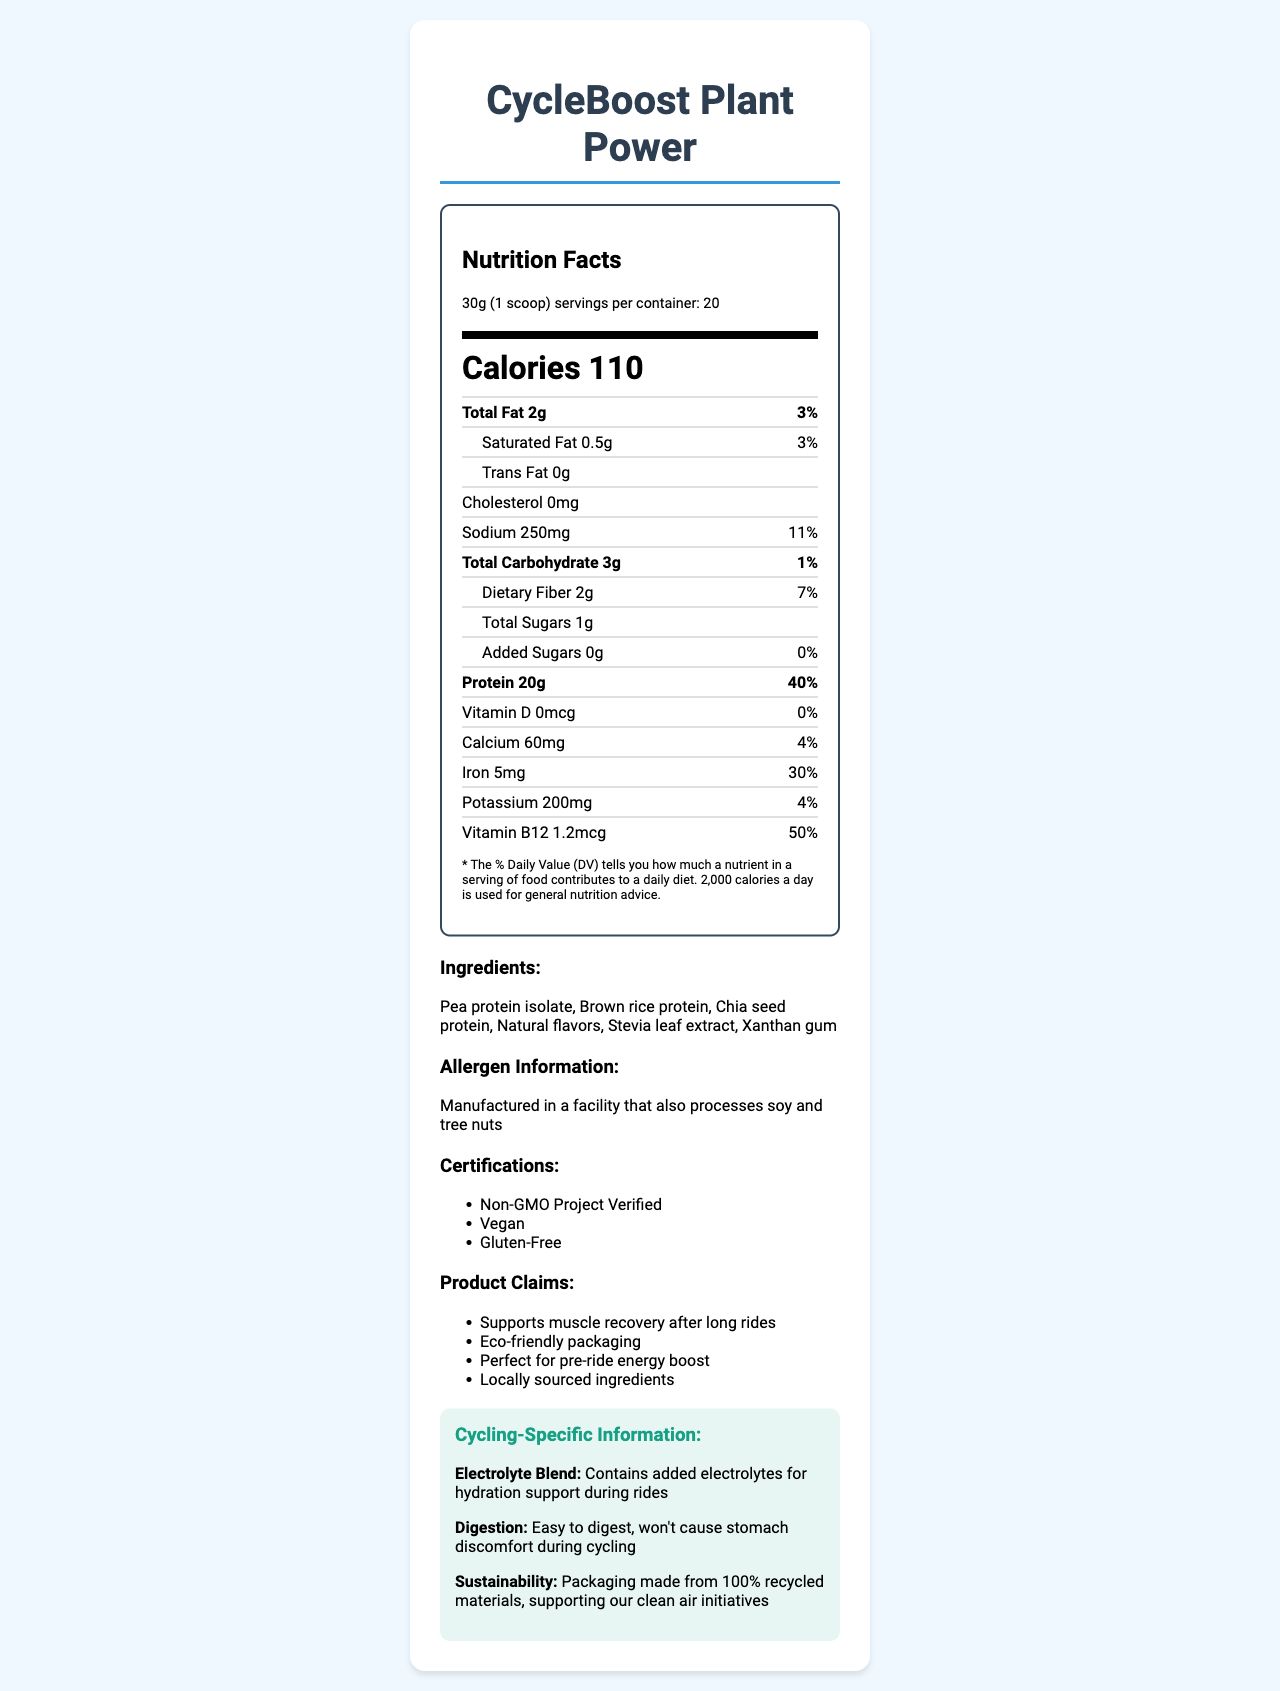What is the serving size of CycleBoost Plant Power? The serving size is mentioned at the beginning of the nutrition label as "30g (1 scoop)".
Answer: 30g (1 scoop) How many servings are there in one container? The number of servings per container is mentioned in the serving information as "20".
Answer: 20 How much protein is in one serving of CycleBoost Plant Power? The protein content is listed in the nutrition facts section, showing "Protein 20g".
Answer: 20g What percentage of the daily value of iron does one serving provide? The daily value percentage for iron is specified in the nutrition facts as "Iron 30%".
Answer: 30% What is the main source of protein in CycleBoost Plant Power? The ingredients list reveals that pea protein isolate is the primary protein source listed first among the ingredients.
Answer: Pea protein isolate What is the total fat content in one serving?  
A. 0g  
B. 1g  
C. 2g  
D. 3g The total fat content per serving is listed as "Total Fat 2g" in the nutrition facts section.
Answer: C Which of the following certifications does CycleBoost Plant Power hold?  
i. USDA Organic  
ii. Vegan  
iii. Non-GMO Project Verified  
iv. Fair Trade  
A. i and ii  
B. ii and iii  
C. i and iv  
D. ii, iii, and iv The certifications listed are "Non-GMO Project Verified" and "Vegan".
Answer: B Does CycleBoost Plant Power contain any added sugars? The nutrition facts show that the added sugars content is "0g", which indicates there are no added sugars.
Answer: No Can you summarize the main nutritional information and features of CycleBoost Plant Power? The summary is derived by highlighting major nutrients, key features, and benefits specific to cycling and sustainability as mentioned in the document.
Answer: CycleBoost Plant Power is a plant-based protein powder with 20g of protein per serving, 110 calories, 2g of total fat, and no added sugars. It is rich in iron and vitamin B12, vegan, gluten-free, and non-GMO. The product is tailored for cyclists, offering hydration support and easy digestion, using sustainable packaging. Where is CycleBoost Plant Power manufactured? The document does not provide any information about the manufacturing location of CycleBoost Plant Power.
Answer: Cannot be determined 